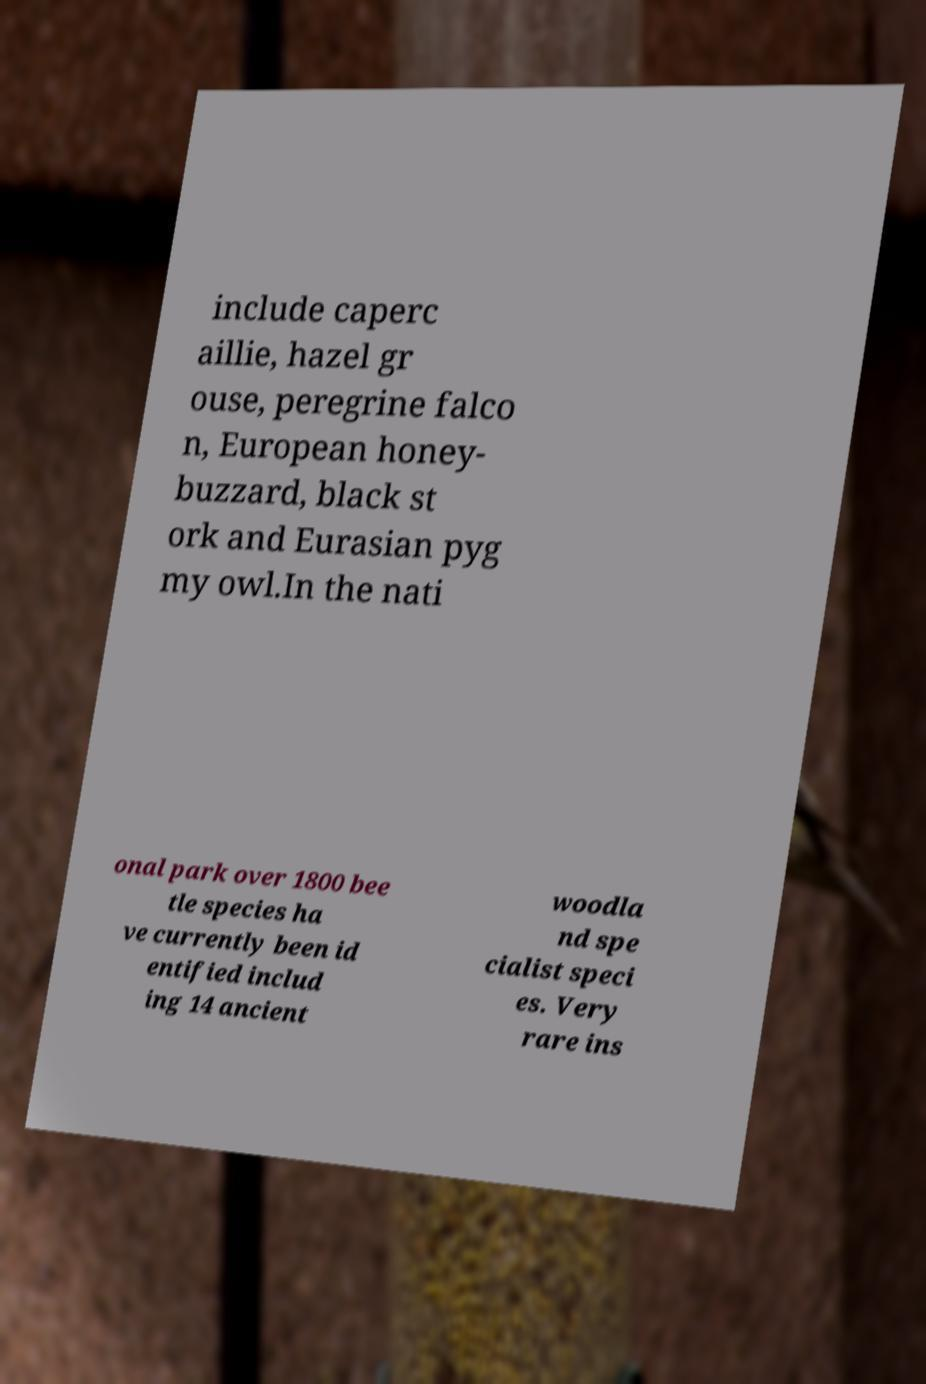Can you read and provide the text displayed in the image?This photo seems to have some interesting text. Can you extract and type it out for me? include caperc aillie, hazel gr ouse, peregrine falco n, European honey- buzzard, black st ork and Eurasian pyg my owl.In the nati onal park over 1800 bee tle species ha ve currently been id entified includ ing 14 ancient woodla nd spe cialist speci es. Very rare ins 